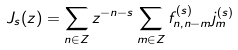Convert formula to latex. <formula><loc_0><loc_0><loc_500><loc_500>J _ { s } ( z ) = \sum _ { n \in Z } z ^ { - n - s } \sum _ { m \in Z } f _ { n , n - m } ^ { ( s ) } j _ { m } ^ { ( s ) }</formula> 